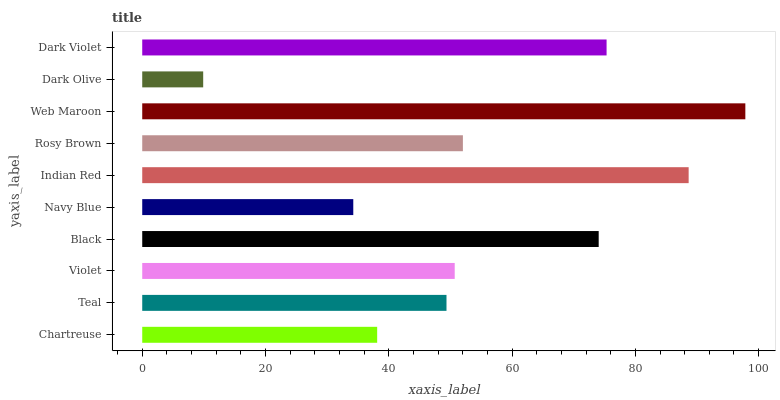Is Dark Olive the minimum?
Answer yes or no. Yes. Is Web Maroon the maximum?
Answer yes or no. Yes. Is Teal the minimum?
Answer yes or no. No. Is Teal the maximum?
Answer yes or no. No. Is Teal greater than Chartreuse?
Answer yes or no. Yes. Is Chartreuse less than Teal?
Answer yes or no. Yes. Is Chartreuse greater than Teal?
Answer yes or no. No. Is Teal less than Chartreuse?
Answer yes or no. No. Is Rosy Brown the high median?
Answer yes or no. Yes. Is Violet the low median?
Answer yes or no. Yes. Is Dark Violet the high median?
Answer yes or no. No. Is Dark Violet the low median?
Answer yes or no. No. 